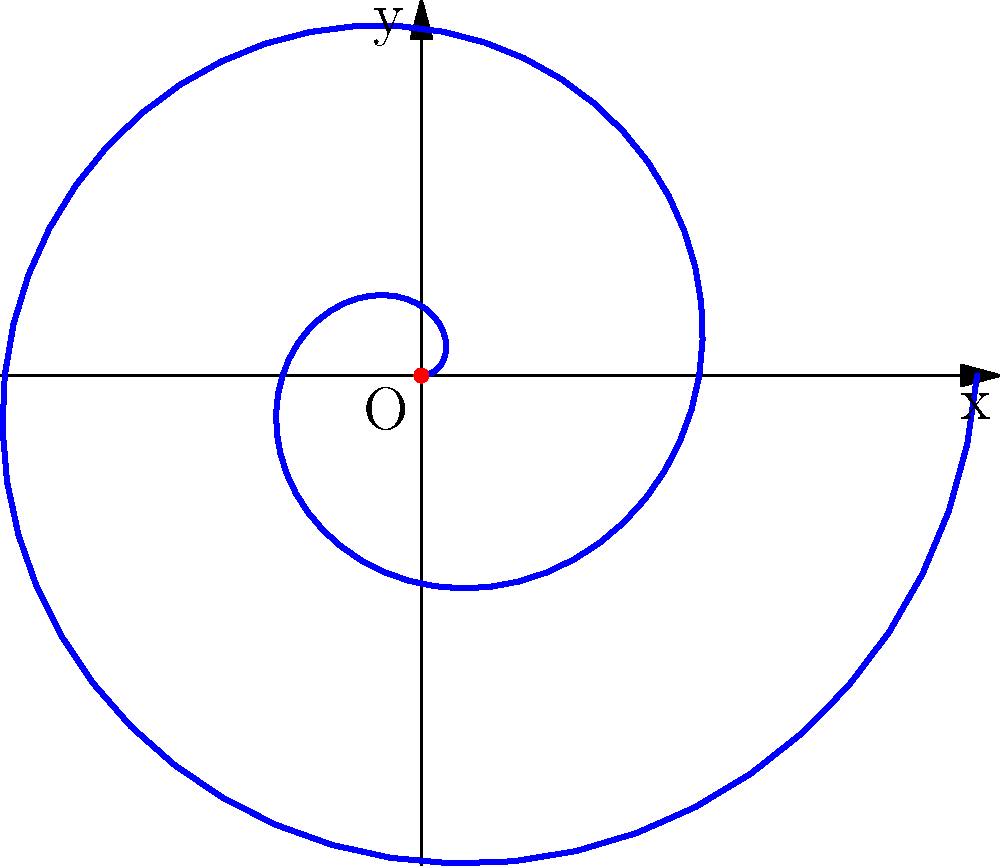In your graphic novel project, you're designing a dreamcatcher inspired by traditional Indigenous art. The spiral pattern of the dreamcatcher can be represented by the polar equation $r = 0.2\theta$. If the dreamcatcher completes two full rotations, what is the total length of the spiral path? To find the length of the spiral path, we'll follow these steps:

1) The formula for the arc length of a polar curve is:

   $$L = \int_{a}^{b} \sqrt{r^2 + \left(\frac{dr}{d\theta}\right)^2} d\theta$$

2) Given: $r = 0.2\theta$
   Therefore, $\frac{dr}{d\theta} = 0.2$

3) Substituting into the formula:

   $$L = \int_{0}^{4\pi} \sqrt{(0.2\theta)^2 + (0.2)^2} d\theta$$

4) Simplify inside the square root:

   $$L = \int_{0}^{4\pi} \sqrt{0.04\theta^2 + 0.04} d\theta$$
   $$L = 0.2\int_{0}^{4\pi} \sqrt{\theta^2 + 1} d\theta$$

5) This integral doesn't have an elementary antiderivative. We can solve it using the substitution $\theta = \sinh(u)$:

   $$L = 0.2\int_{0}^{\sinh^{-1}(4\pi)} \sqrt{\sinh^2(u) + 1} \cosh(u) du$$

6) Simplify using the identity $\sinh^2(u) + 1 = \cosh^2(u)$:

   $$L = 0.2\int_{0}^{\sinh^{-1}(4\pi)} \cosh^2(u) du$$

7) The antiderivative of $\cosh^2(u)$ is $\frac{1}{4}(2u + \sinh(2u))$, so:

   $$L = 0.2 \left[\frac{1}{4}(2u + \sinh(2u))\right]_{0}^{\sinh^{-1}(4\pi)}$$

8) Evaluate:

   $$L = 0.1 \left(2\sinh^{-1}(4\pi) + \sinh(2\sinh^{-1}(4\pi)) - 0\right)$$

9) Simplify using $\sinh(2\sinh^{-1}(x)) = 2x\sqrt{1+x^2}$:

   $$L = 0.1 \left(2\sinh^{-1}(4\pi) + 8\pi\sqrt{1+(4\pi)^2}\right)$$

10) Calculate the numerical value:

    $$L \approx 15.9947$$
Answer: 15.9947 units 